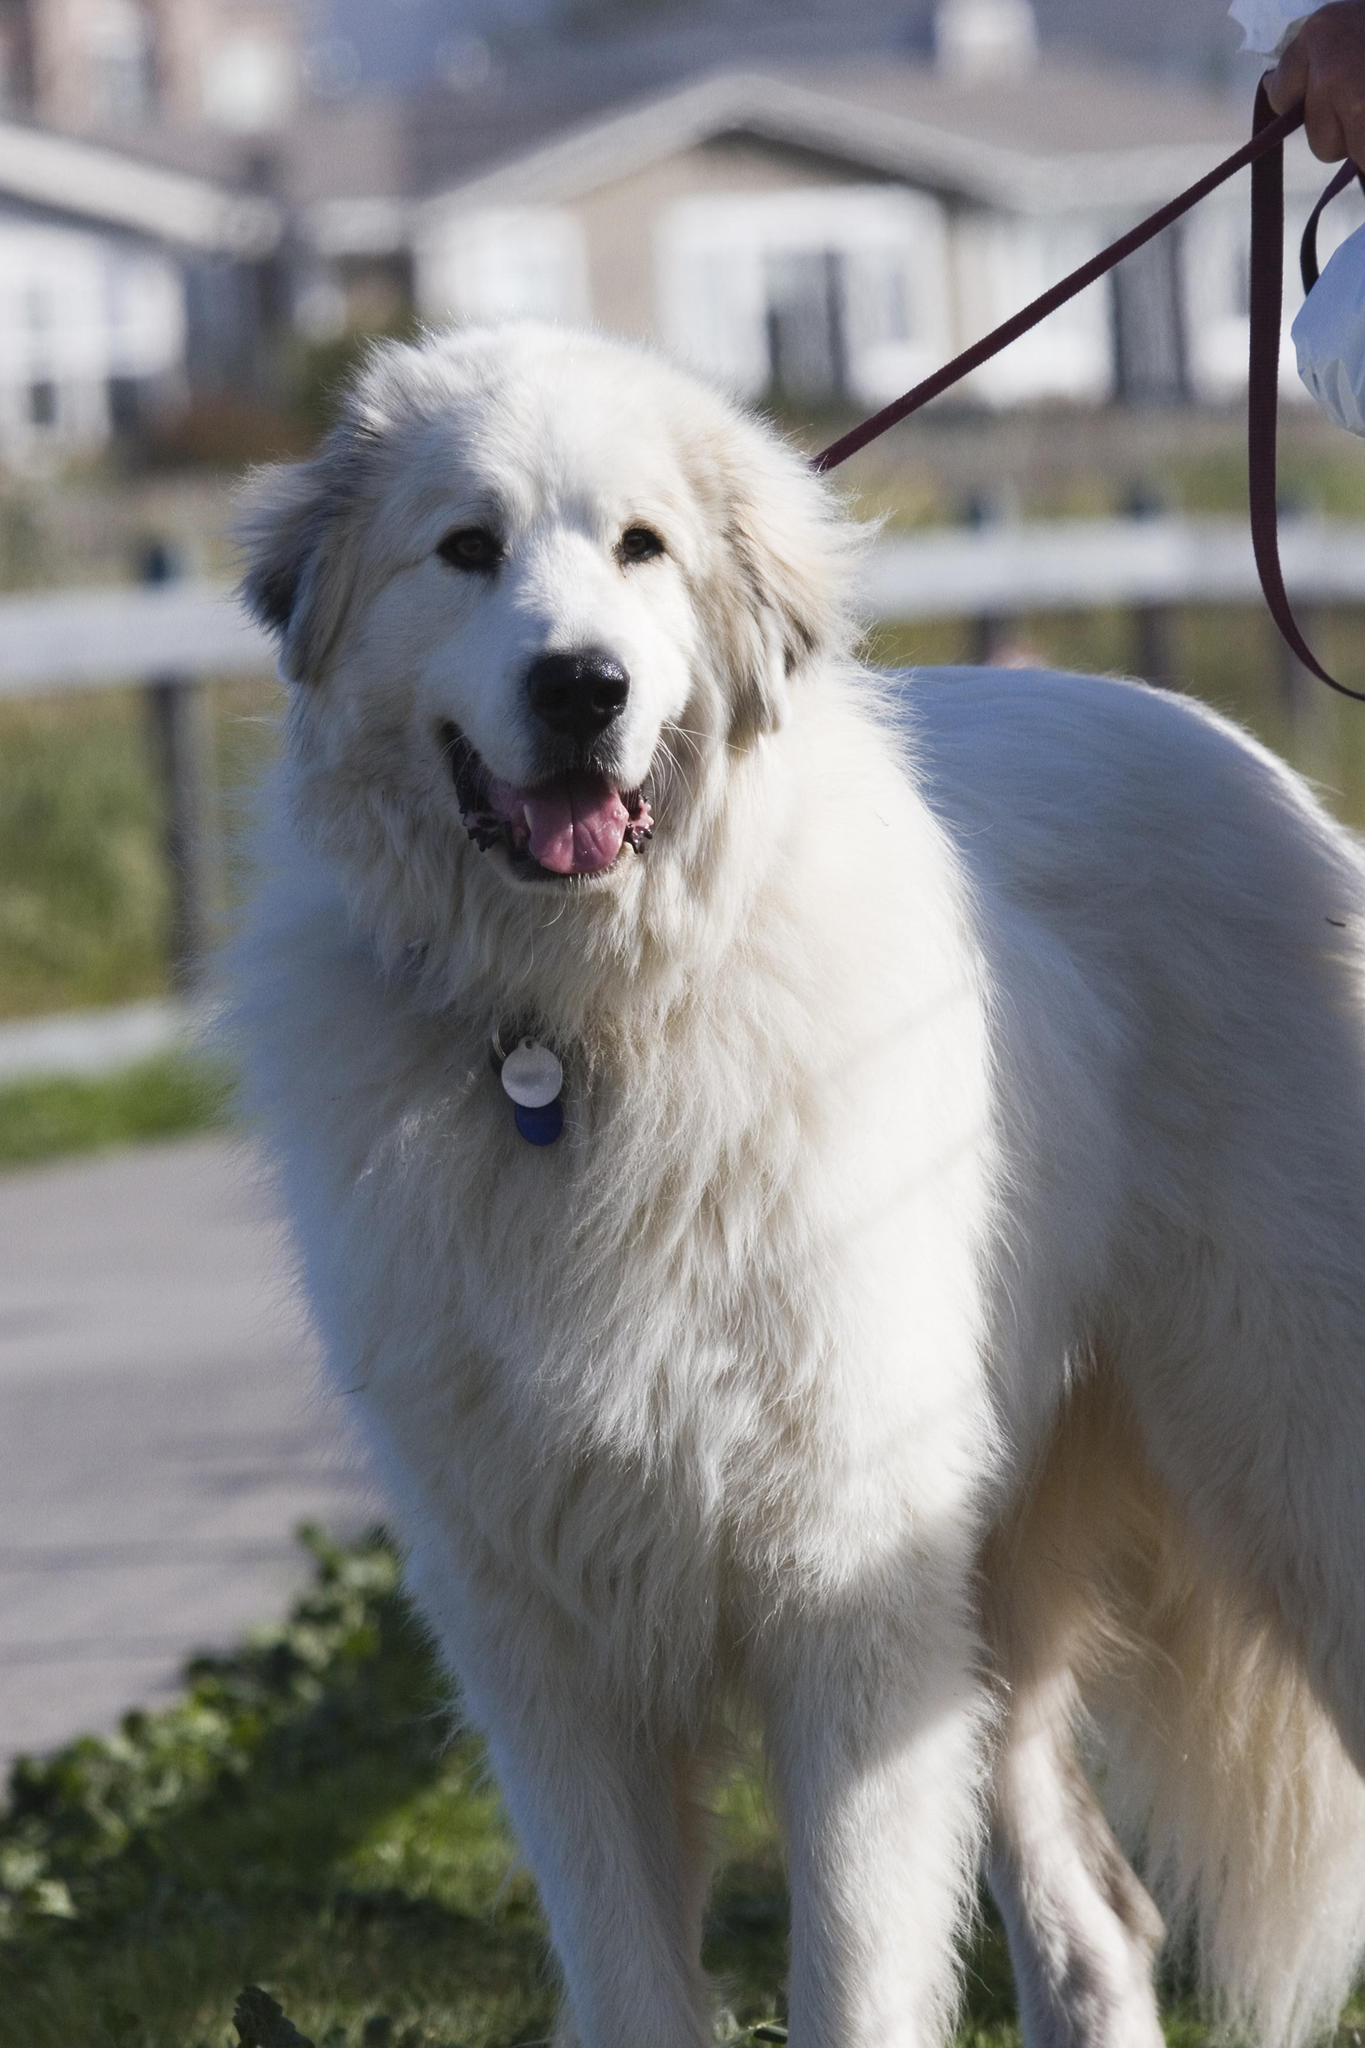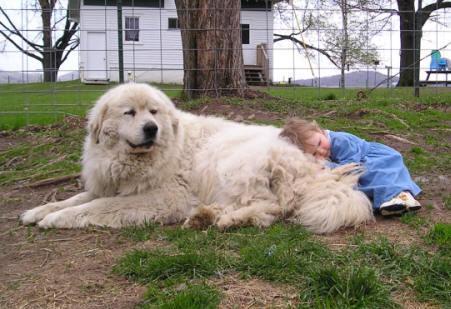The first image is the image on the left, the second image is the image on the right. Analyze the images presented: Is the assertion "There is a large dog with a child in one image, and a similar dog with it's mouth open in the other." valid? Answer yes or no. Yes. The first image is the image on the left, the second image is the image on the right. For the images displayed, is the sentence "One dog is laying in the dirt." factually correct? Answer yes or no. Yes. 